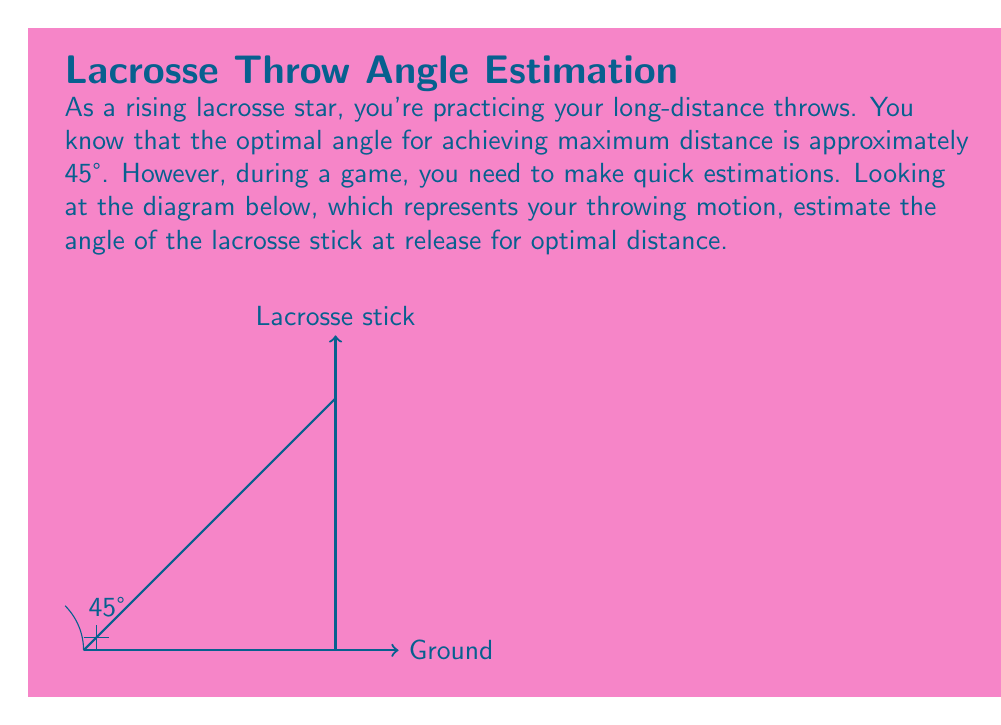Could you help me with this problem? To estimate the angle of the lacrosse stick for optimal distance, we can use visual cues and our knowledge of right angles:

1) We know that a right angle is 90°.
2) The optimal angle for maximum distance is approximately 45°.
3) In the diagram, we can see that 45° is half of the right angle formed by the ground and the vertical line.
4) The lacrosse stick appears to be positioned roughly halfway between the ground and the vertical line.

Given these observations:

$$\text{Estimated angle} \approx \frac{1}{2} \times 90° = 45°$$

This estimation aligns with the known optimal angle for achieving maximum distance in projectile motion, which is indeed 45° in ideal conditions (ignoring air resistance).

In a real game situation, you would use this visual estimation technique to quickly position your lacrosse stick at approximately a 45° angle relative to the ground for optimal distance throws.
Answer: 45° 